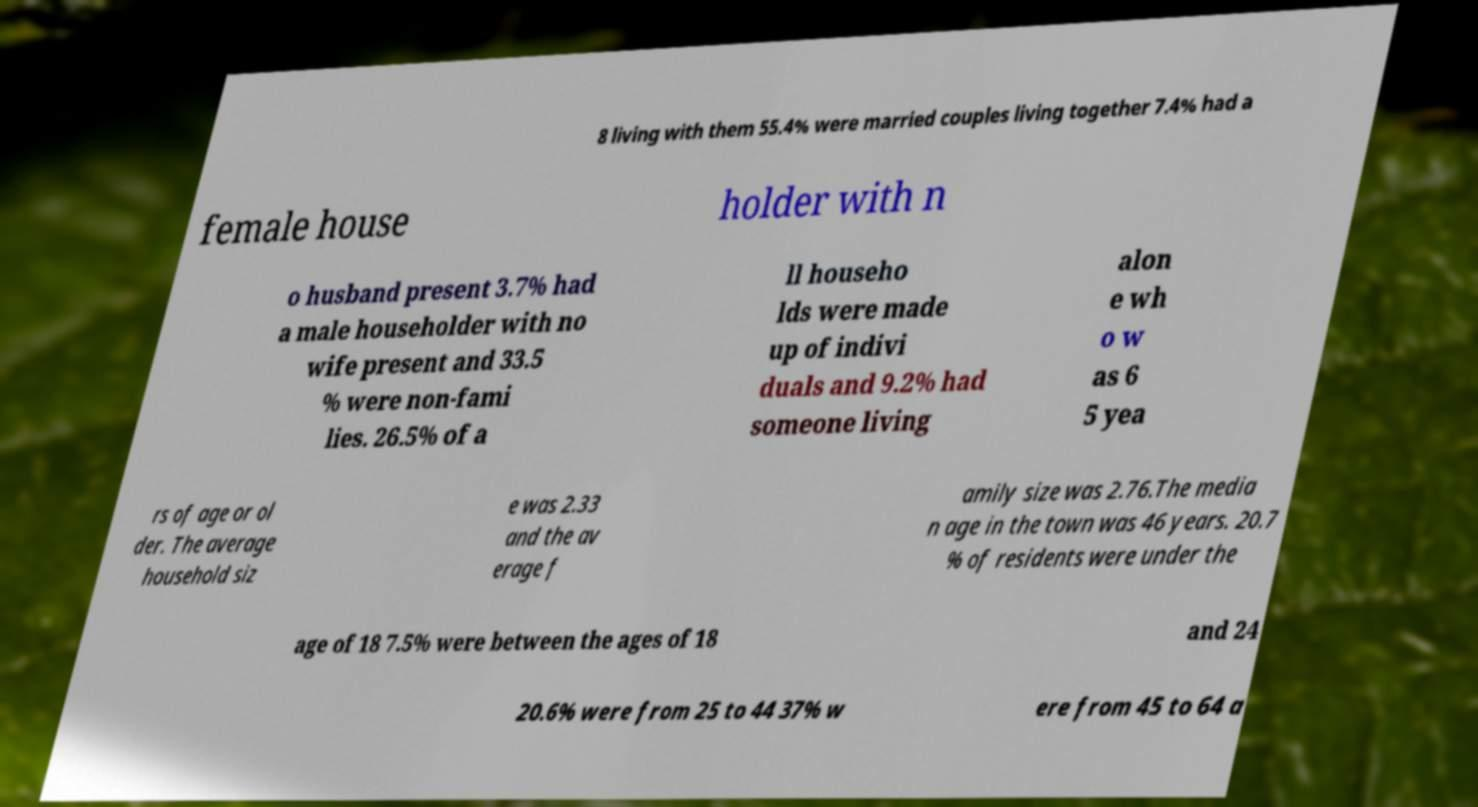Can you accurately transcribe the text from the provided image for me? 8 living with them 55.4% were married couples living together 7.4% had a female house holder with n o husband present 3.7% had a male householder with no wife present and 33.5 % were non-fami lies. 26.5% of a ll househo lds were made up of indivi duals and 9.2% had someone living alon e wh o w as 6 5 yea rs of age or ol der. The average household siz e was 2.33 and the av erage f amily size was 2.76.The media n age in the town was 46 years. 20.7 % of residents were under the age of 18 7.5% were between the ages of 18 and 24 20.6% were from 25 to 44 37% w ere from 45 to 64 a 